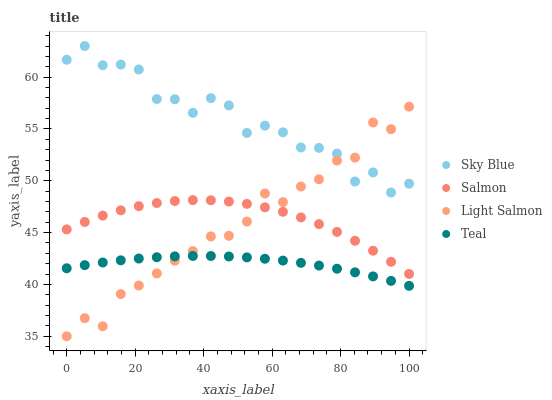Does Teal have the minimum area under the curve?
Answer yes or no. Yes. Does Sky Blue have the maximum area under the curve?
Answer yes or no. Yes. Does Light Salmon have the minimum area under the curve?
Answer yes or no. No. Does Light Salmon have the maximum area under the curve?
Answer yes or no. No. Is Teal the smoothest?
Answer yes or no. Yes. Is Sky Blue the roughest?
Answer yes or no. Yes. Is Light Salmon the smoothest?
Answer yes or no. No. Is Light Salmon the roughest?
Answer yes or no. No. Does Light Salmon have the lowest value?
Answer yes or no. Yes. Does Salmon have the lowest value?
Answer yes or no. No. Does Sky Blue have the highest value?
Answer yes or no. Yes. Does Light Salmon have the highest value?
Answer yes or no. No. Is Salmon less than Sky Blue?
Answer yes or no. Yes. Is Sky Blue greater than Teal?
Answer yes or no. Yes. Does Light Salmon intersect Teal?
Answer yes or no. Yes. Is Light Salmon less than Teal?
Answer yes or no. No. Is Light Salmon greater than Teal?
Answer yes or no. No. Does Salmon intersect Sky Blue?
Answer yes or no. No. 